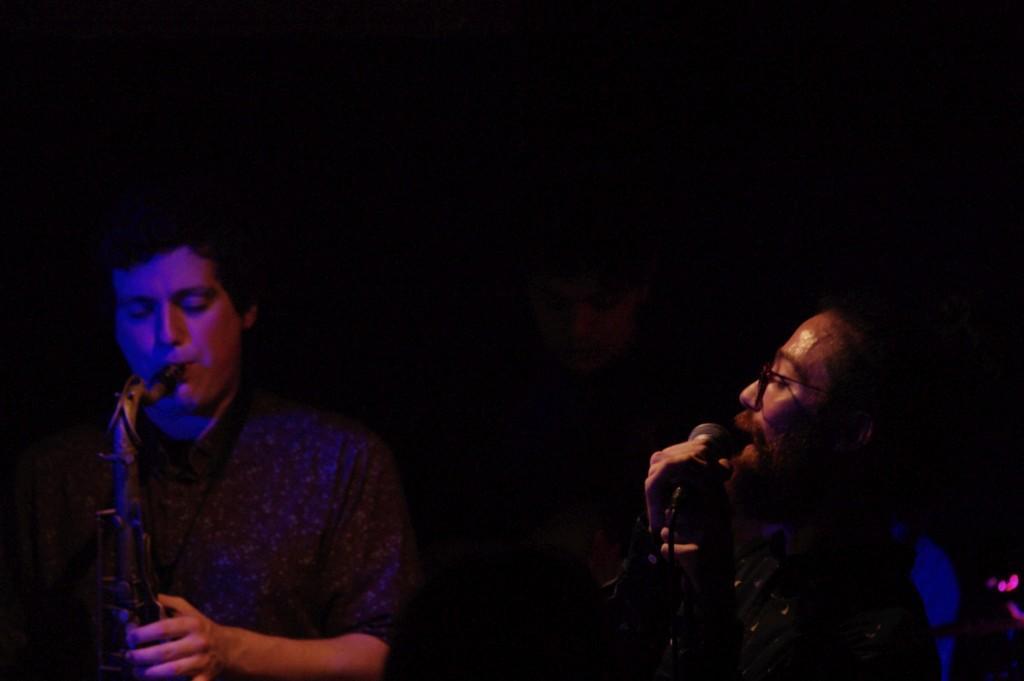Can you describe this image briefly? In the picture we can see a two men are holding a musical instruments and playing it and in the back side there is a dark. 